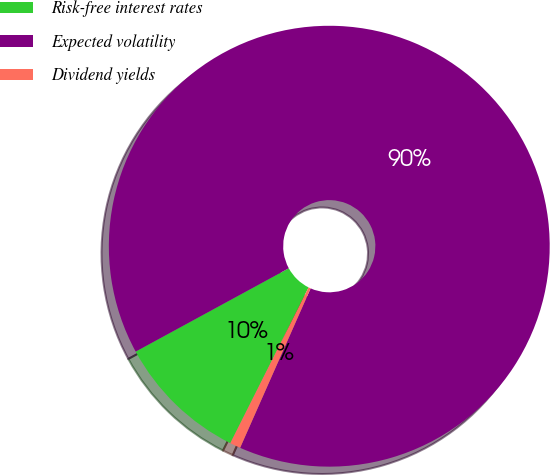<chart> <loc_0><loc_0><loc_500><loc_500><pie_chart><fcel>Risk-free interest rates<fcel>Expected volatility<fcel>Dividend yields<nl><fcel>9.66%<fcel>89.56%<fcel>0.78%<nl></chart> 